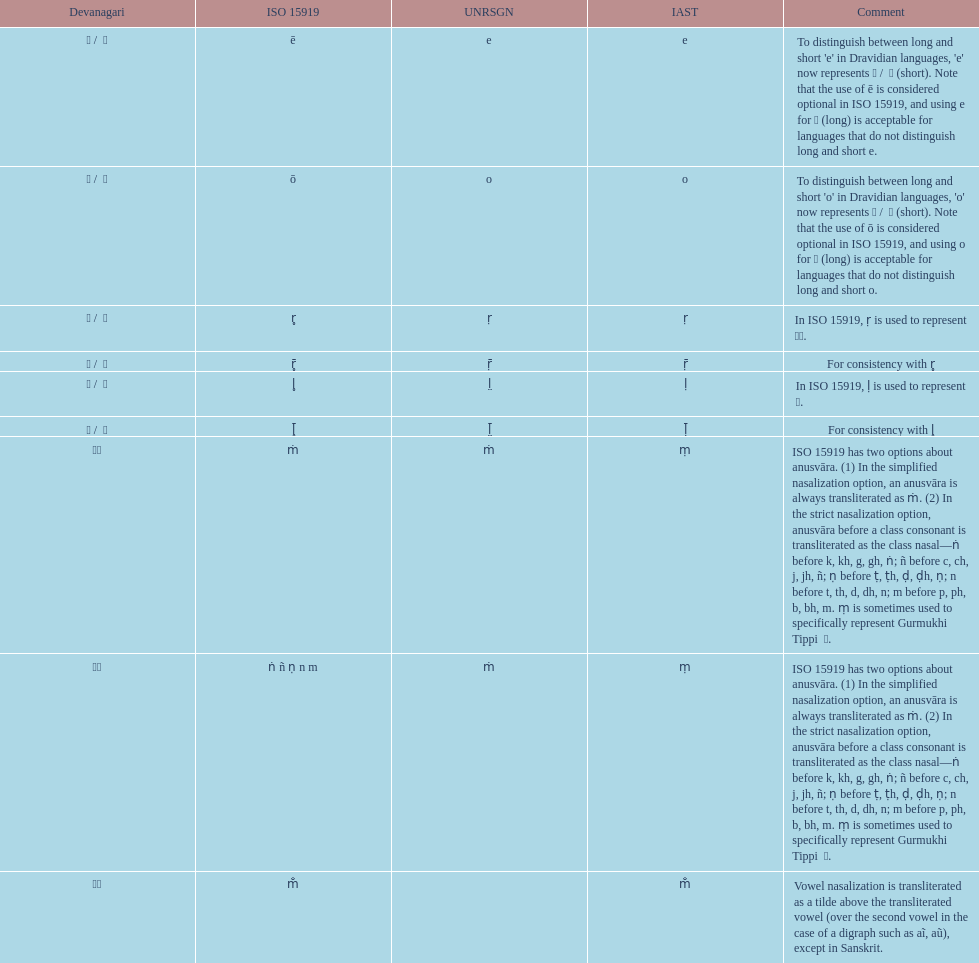What unrsgn is listed previous to the o? E. 